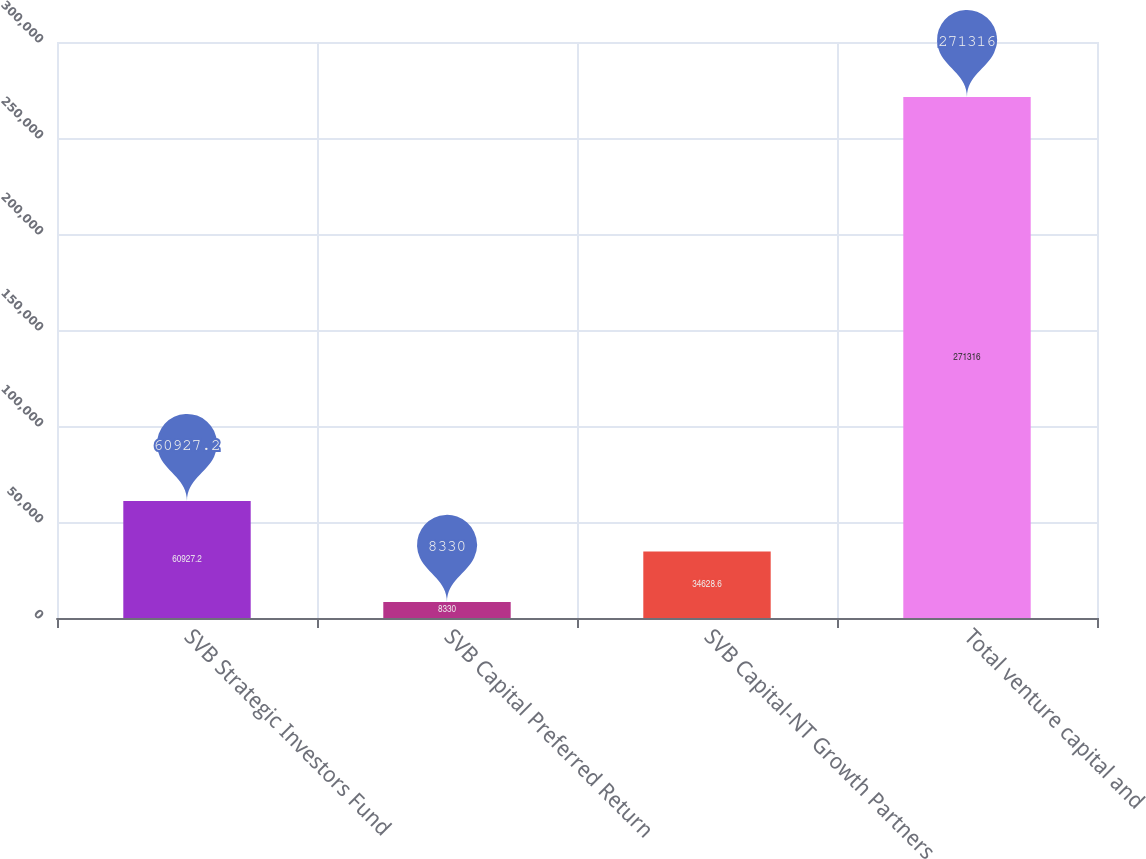Convert chart to OTSL. <chart><loc_0><loc_0><loc_500><loc_500><bar_chart><fcel>SVB Strategic Investors Fund<fcel>SVB Capital Preferred Return<fcel>SVB Capital-NT Growth Partners<fcel>Total venture capital and<nl><fcel>60927.2<fcel>8330<fcel>34628.6<fcel>271316<nl></chart> 